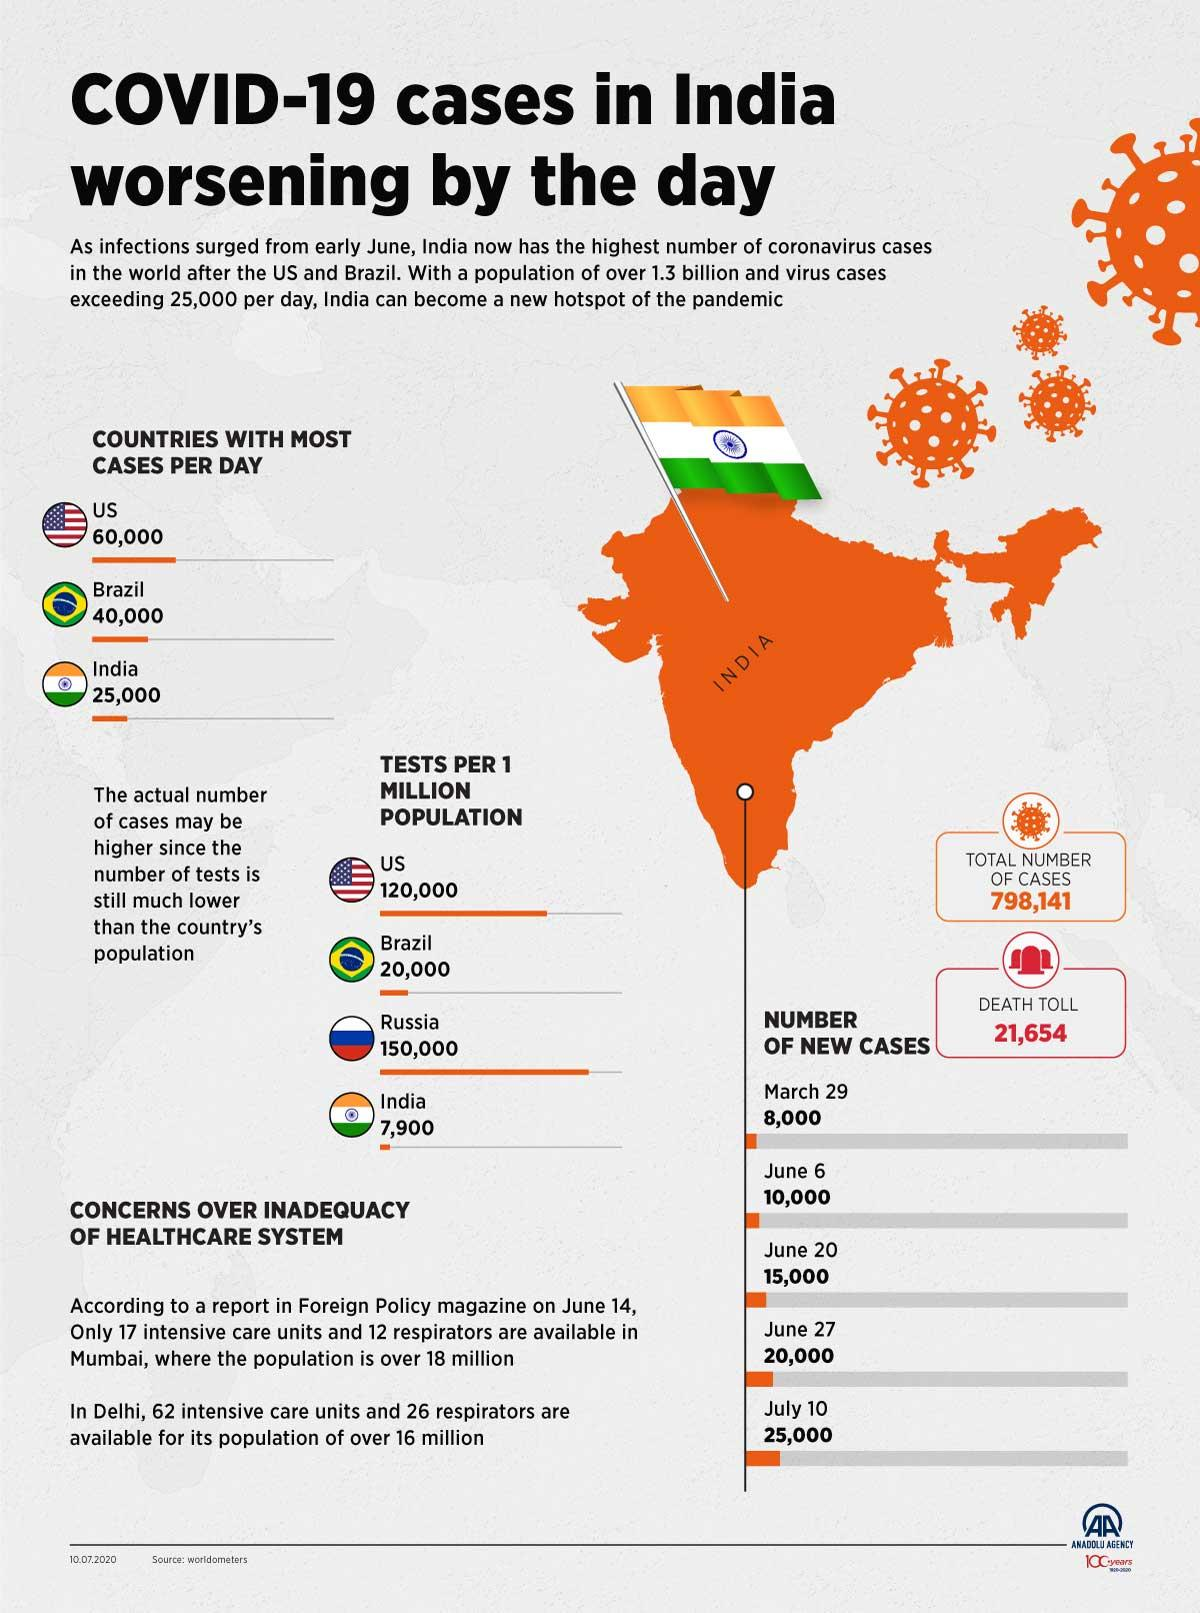Point out several critical features in this image. The COVID-19 pandemic resulted in the loss of 21,654 lives. The number of tests per 1 million population in India is lower than that in the US. Specifically, there are approximately 1,12,100 tests per 1 million population in India, while the corresponding figure in the US is higher at around 4,20,000 tests per 1 million population. The number of cases per day between the United States and Brazil is approximately 20,000. The number of cases in India increased by 17,000 from March 29 to July 10. 